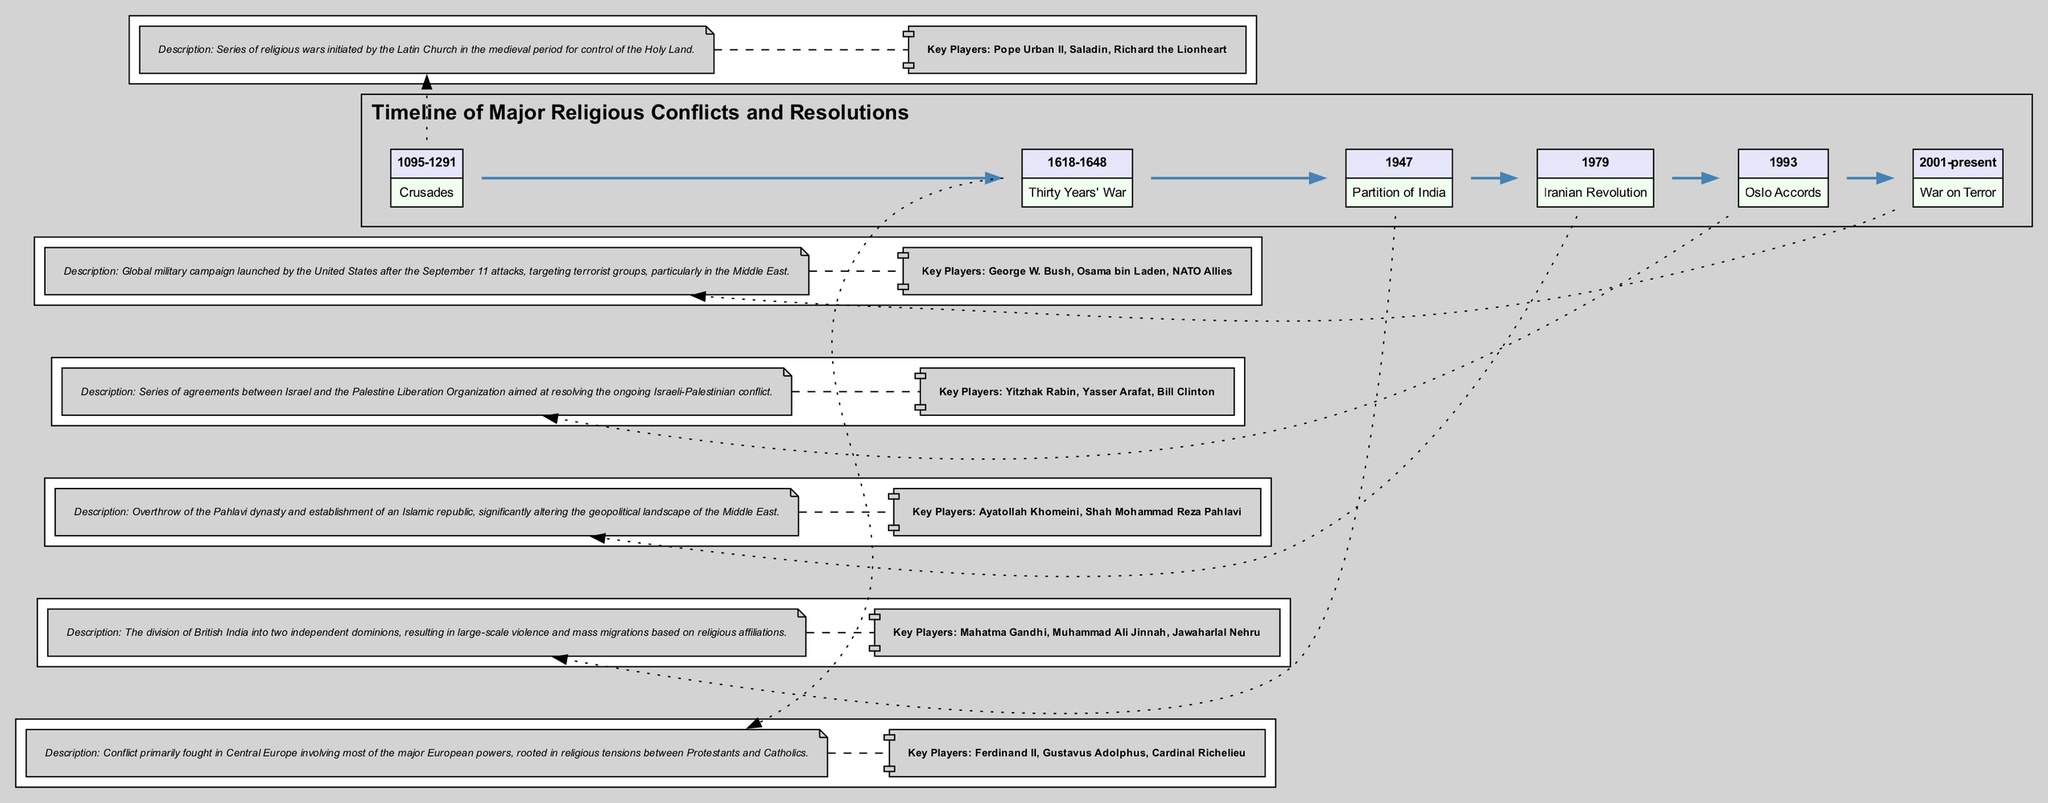What is the date range of the Crusades? The diagram indicates that the Crusades occurred from 1095 to 1291, as shown in the event box for the Crusades.
Answer: 1095-1291 Who were the key players in the Thirty Years' War? Referring to the section of the diagram that describes the Thirty Years' War, the key players listed are Ferdinand II, Gustavus Adolphus, and Cardinal Richelieu.
Answer: Ferdinand II, Gustavus Adolphus, Cardinal Richelieu How many major conflicts are represented in the diagram? By counting the number of events listed in the timeline, there are six major conflicts depicted in the diagram.
Answer: 6 What event is associated with Mahatma Gandhi? The description for the Partition of India highlights Mahatma Gandhi as one of the key figures involved, thus linking him to that event.
Answer: Partition of India What significant change did the Iranian Revolution bring about? The entry about the Iranian Revolution explains that it led to the establishment of an Islamic republic, which is a significant change in governance for Iran.
Answer: Establishment of an Islamic republic Which event directly involves Yitzhak Rabin? The Oslo Accords section of the diagram lists Yitzhak Rabin as one of the key players, directly associating him with that event.
Answer: Oslo Accords Which two religious groups were primarily involved in the Thirty Years' War? The description provided for the Thirty Years' War outlines that it was rooted in religious tensions between Protestants and Catholics, indicating these two groups' involvement.
Answer: Protestants and Catholics What type of conflict is indicated for the War on Terror? The diagram specifically describes the War on Terror as a global military campaign, illustrating its broad nature and intent.
Answer: Global military campaign 